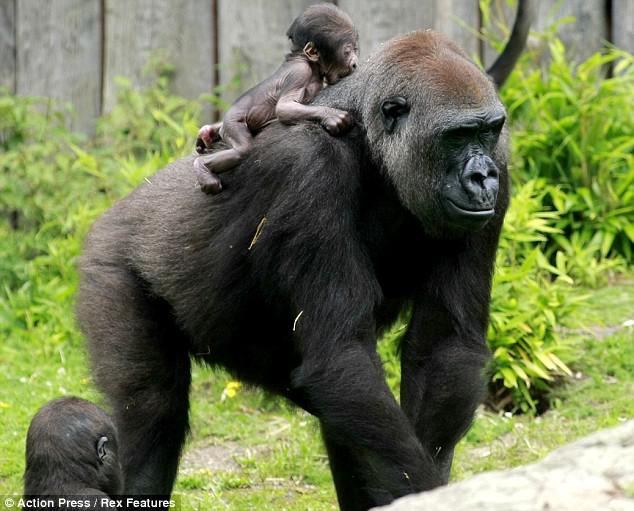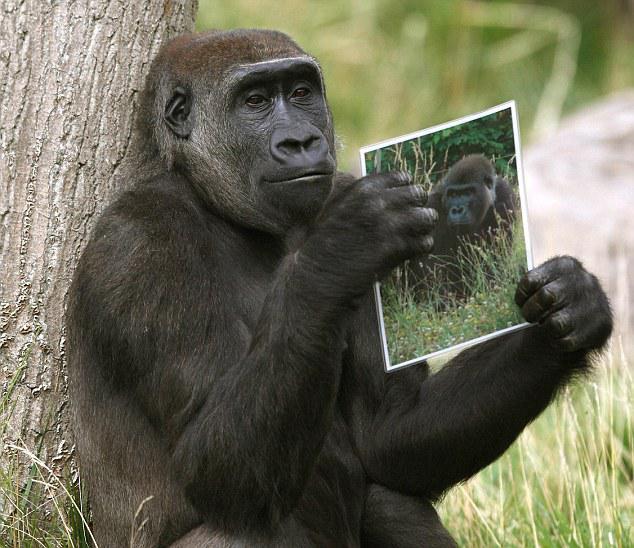The first image is the image on the left, the second image is the image on the right. Examine the images to the left and right. Is the description "Two of the apes are posed in contact and face to face, but neither is held off the ground by the other." accurate? Answer yes or no. No. The first image is the image on the left, the second image is the image on the right. Analyze the images presented: Is the assertion "A baby gorilla is with an adult gorilla in at least one of the images." valid? Answer yes or no. Yes. 